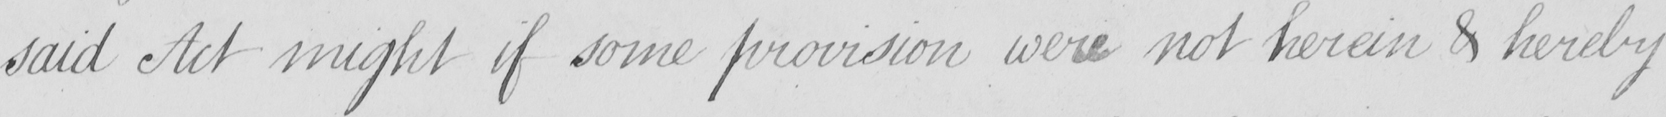What text is written in this handwritten line? said Act might if some provision were not herein & hereby 